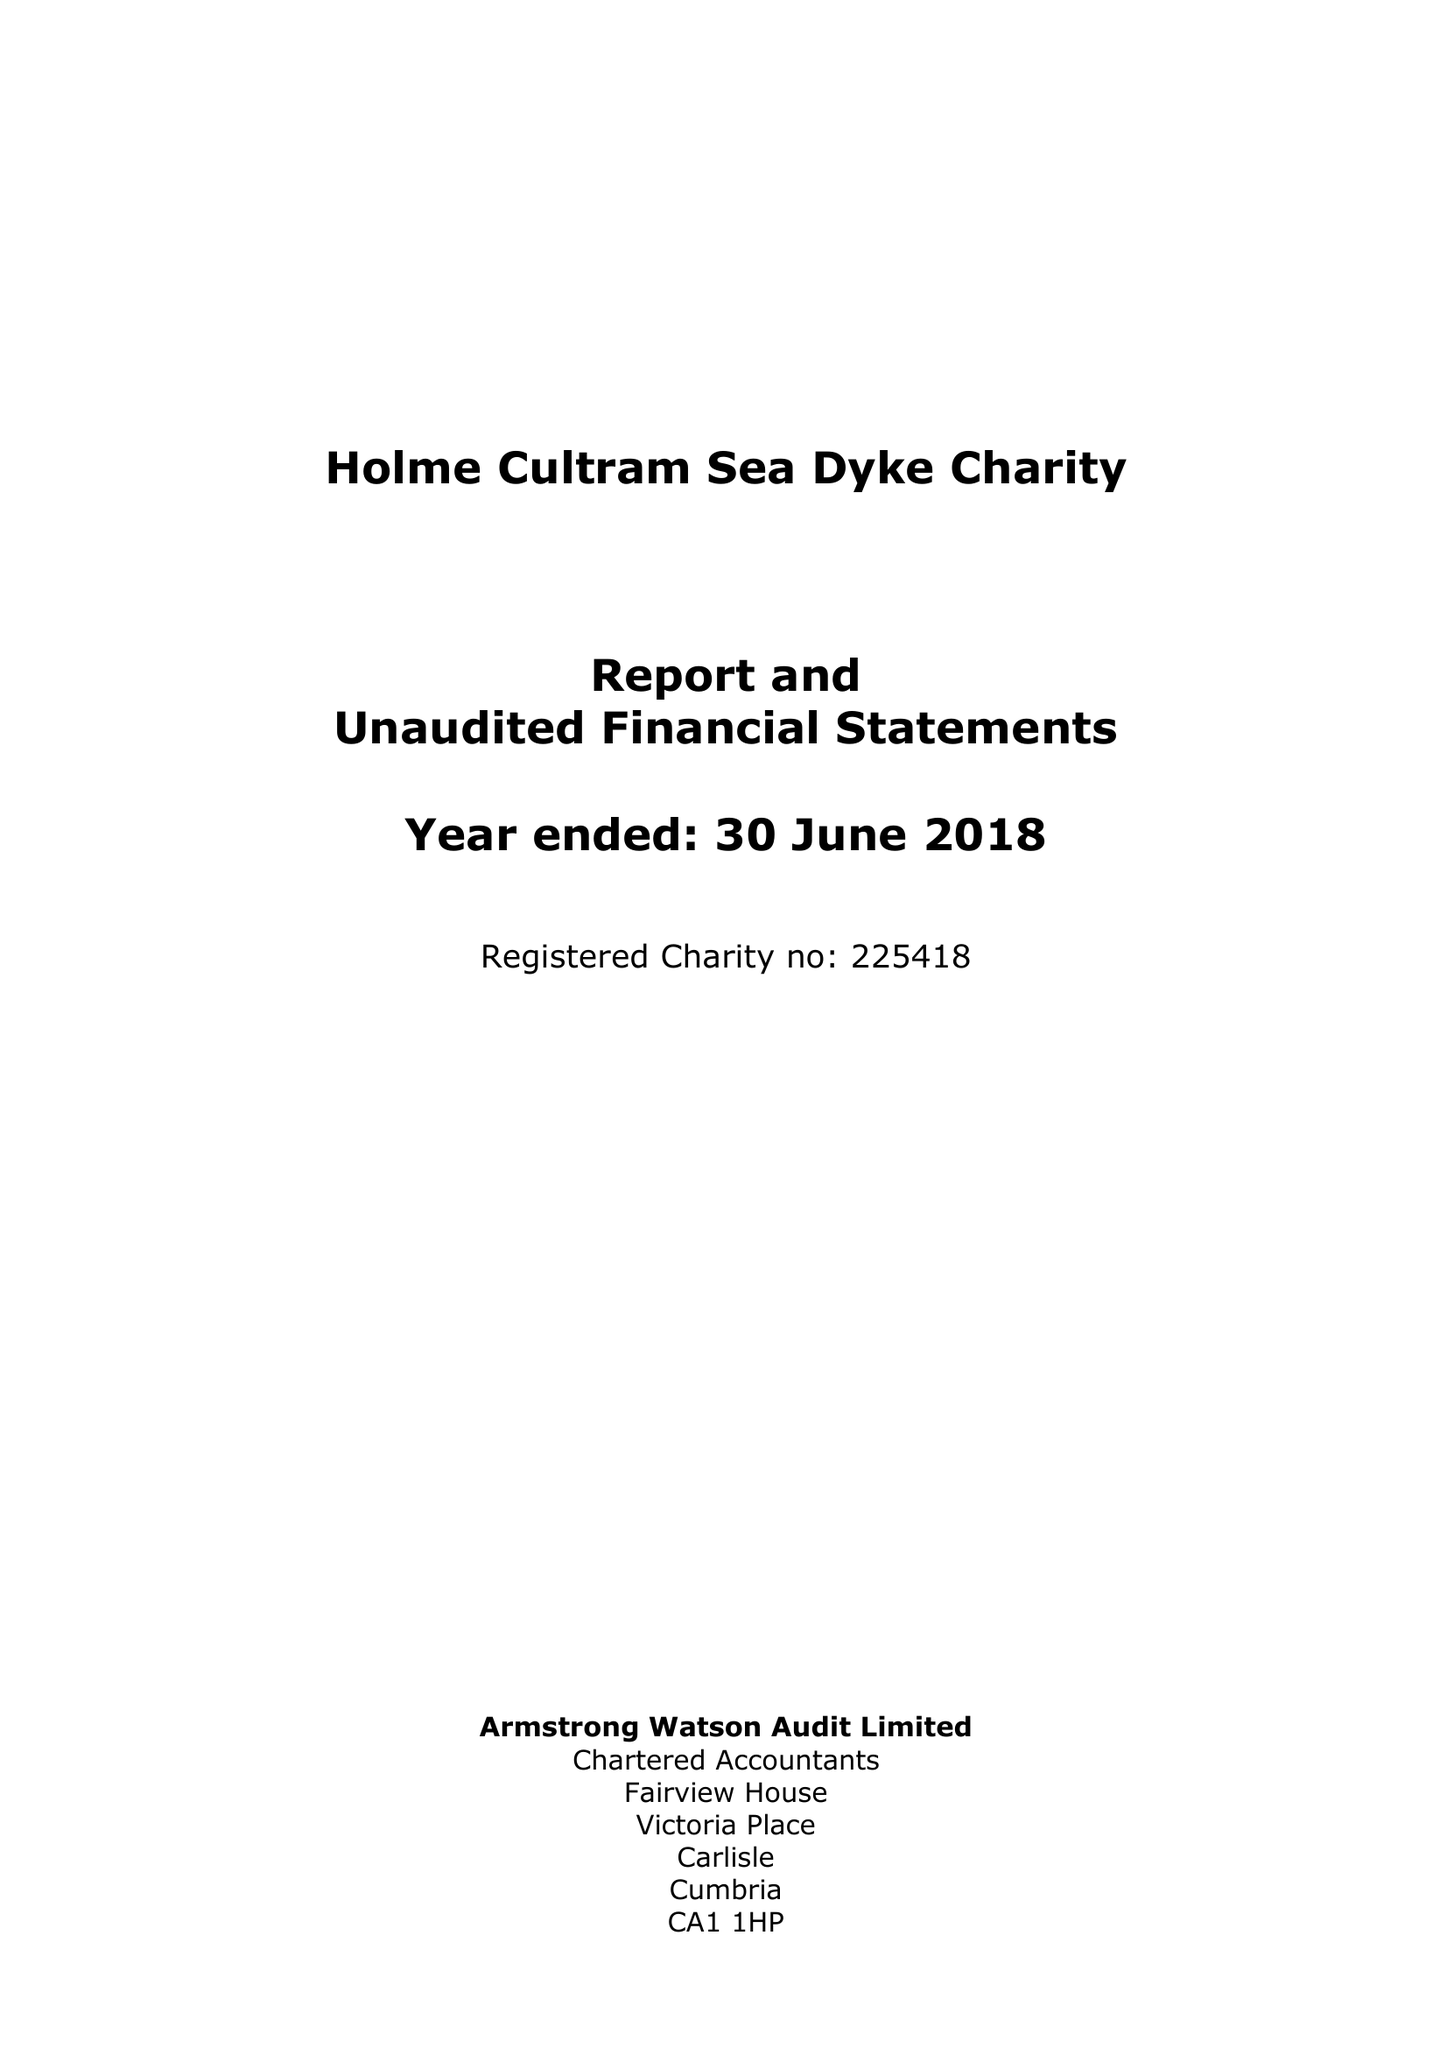What is the value for the report_date?
Answer the question using a single word or phrase. 2018-06-30 